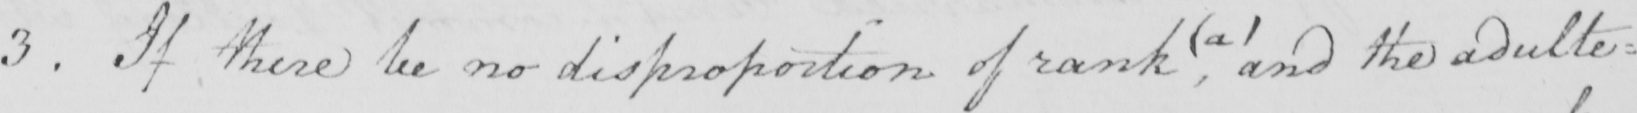Please transcribe the handwritten text in this image. 3 . If there be no disproportion of rank ,  ( a )  and the adulte= 